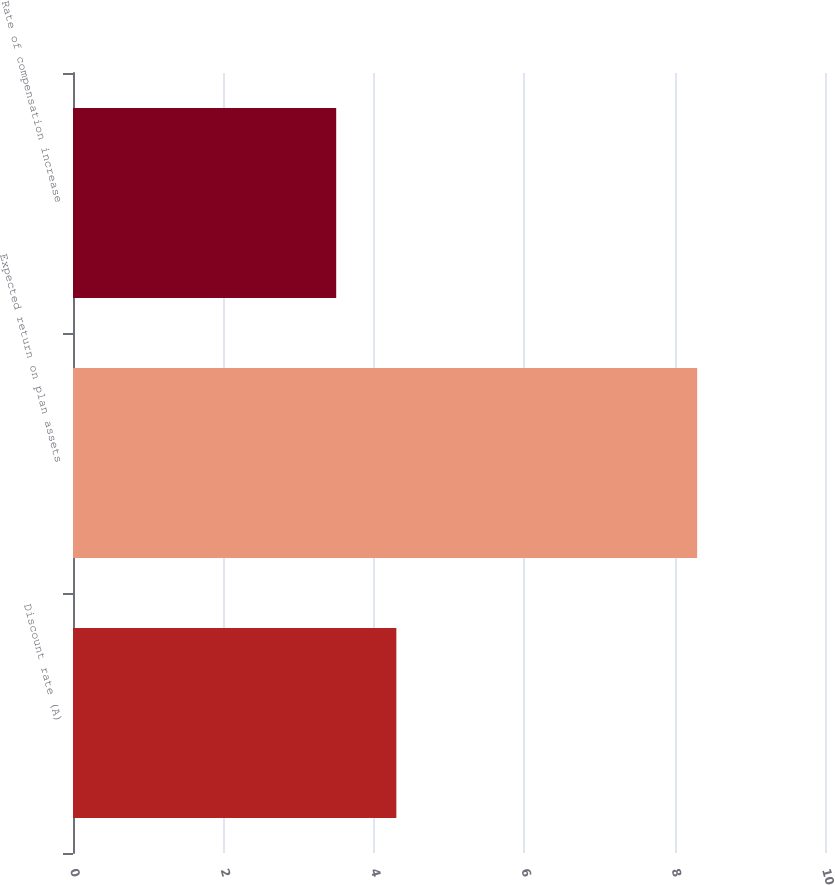<chart> <loc_0><loc_0><loc_500><loc_500><bar_chart><fcel>Discount rate (A)<fcel>Expected return on plan assets<fcel>Rate of compensation increase<nl><fcel>4.3<fcel>8.3<fcel>3.5<nl></chart> 